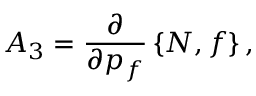<formula> <loc_0><loc_0><loc_500><loc_500>A _ { 3 } = \frac { \partial } { \partial p _ { f } } \left \{ N , f \right \} ,</formula> 